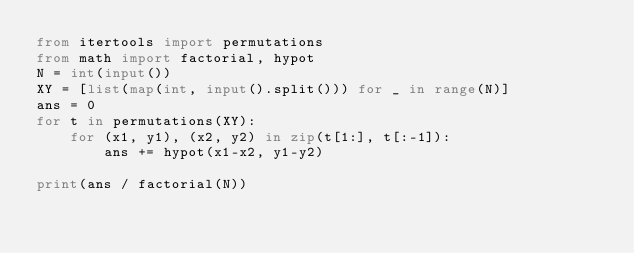<code> <loc_0><loc_0><loc_500><loc_500><_Python_>from itertools import permutations
from math import factorial, hypot
N = int(input())
XY = [list(map(int, input().split())) for _ in range(N)]
ans = 0
for t in permutations(XY):
    for (x1, y1), (x2, y2) in zip(t[1:], t[:-1]):
        ans += hypot(x1-x2, y1-y2)

print(ans / factorial(N))
</code> 